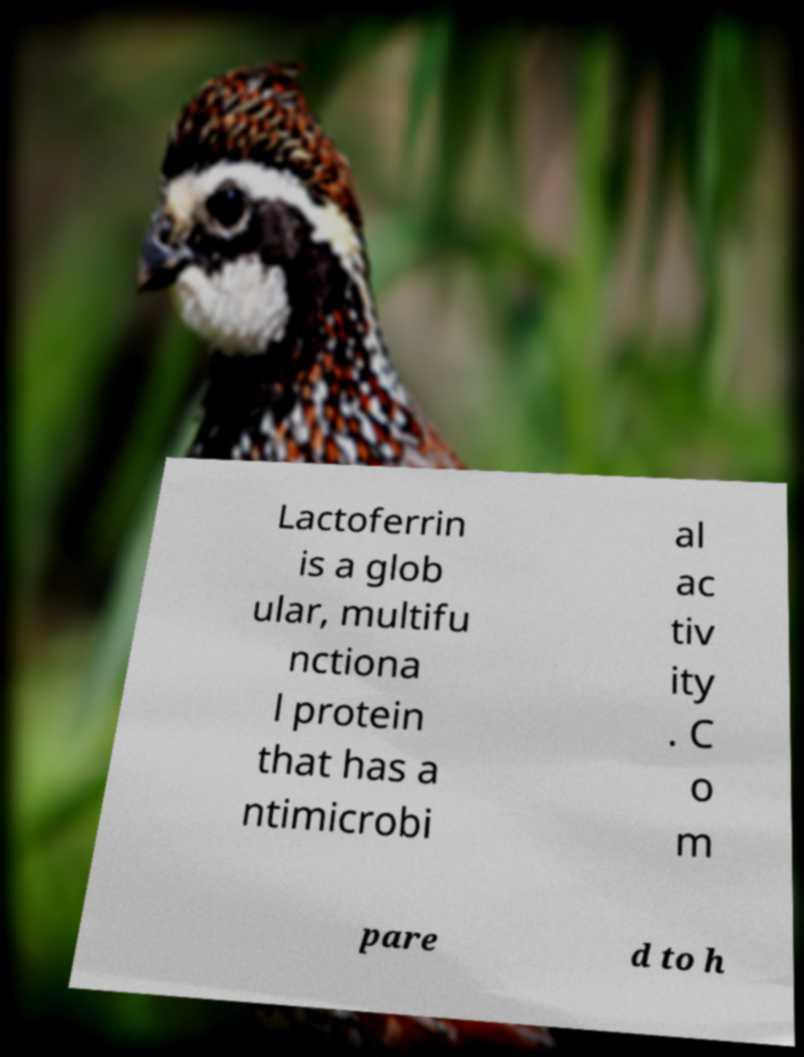There's text embedded in this image that I need extracted. Can you transcribe it verbatim? Lactoferrin is a glob ular, multifu nctiona l protein that has a ntimicrobi al ac tiv ity . C o m pare d to h 